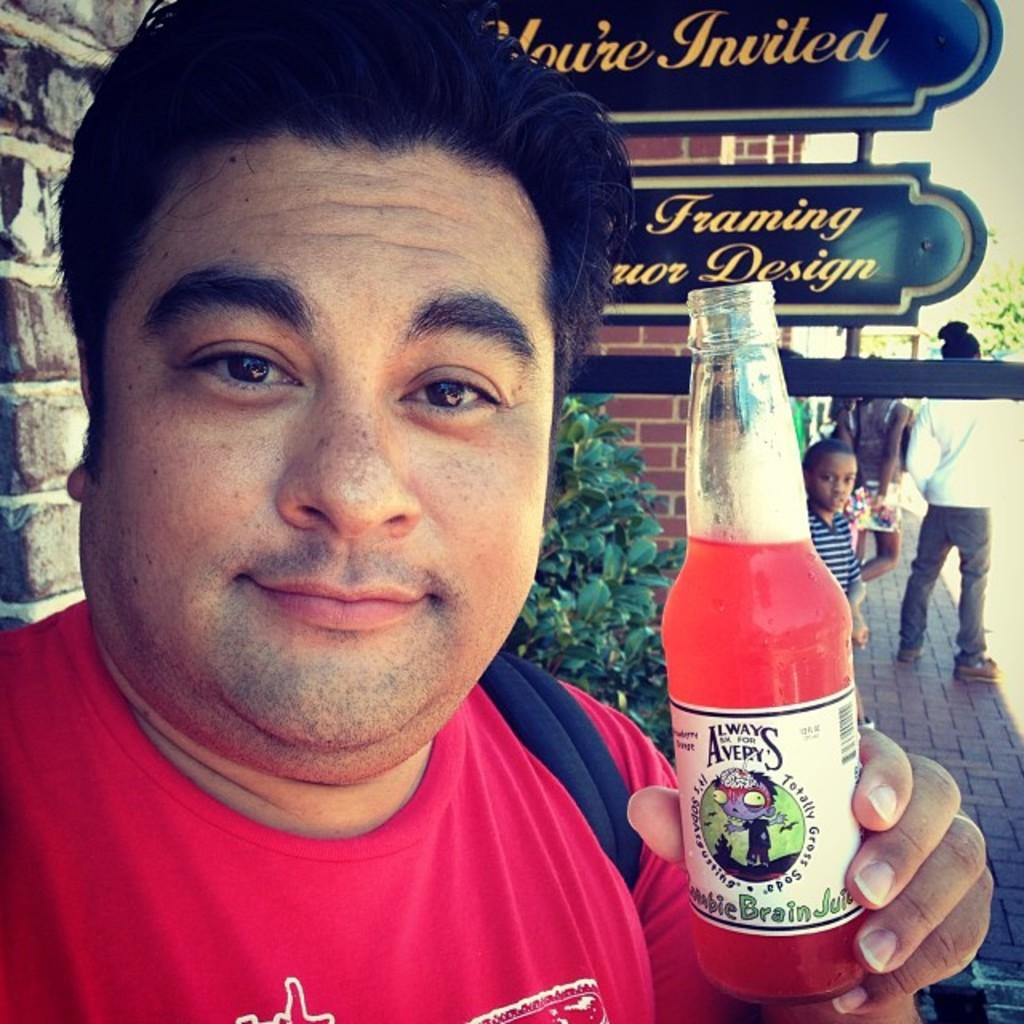Who is present in the image? There is a man in the image. What is the man wearing? The man is wearing a red t-shirt. What is the man holding in the image? The man is holding a bottle. What can be seen in the background of the image? There are boards, people, a wall, and plants visible in the background of the image. What type of space-themed cake can be seen in the image? There is no cake present in the image, let alone a space-themed one. What is the man doing with his lip in the image? There is no mention of the man's lip in the image, and no action involving it is depicted. 